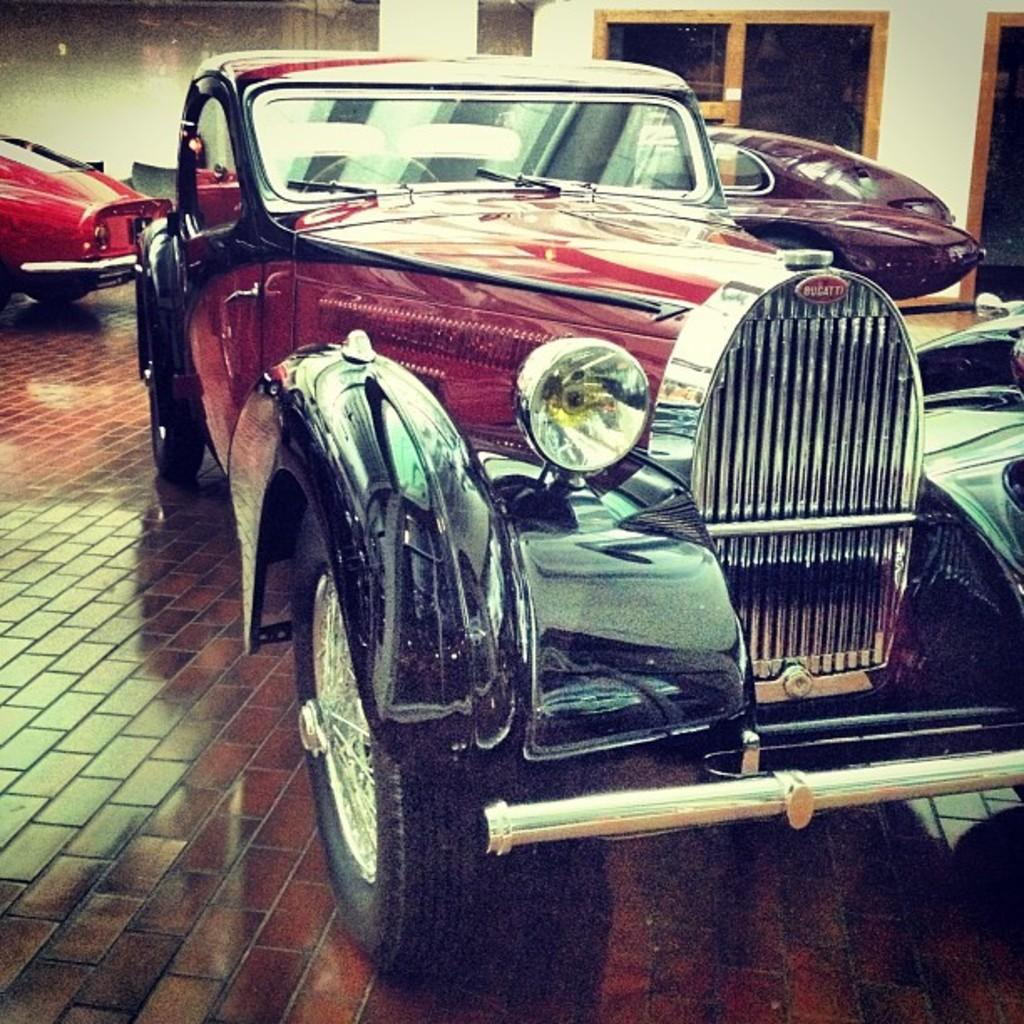What is the main subject in the center of the image? There is a vehicle in the center of the image. Can you describe the surroundings of the main subject? There are vehicles visible in the background of the image, along with a window and a wall. What is the surface on which the main subject is placed? There is a floor visible at the bottom of the image. What type of root can be seen growing through the floor in the image? There is no root visible in the image; the floor is clear of any plant growth. What is the name of the bird perched on the vehicle in the image? There is no bird present on the vehicle in the image. 